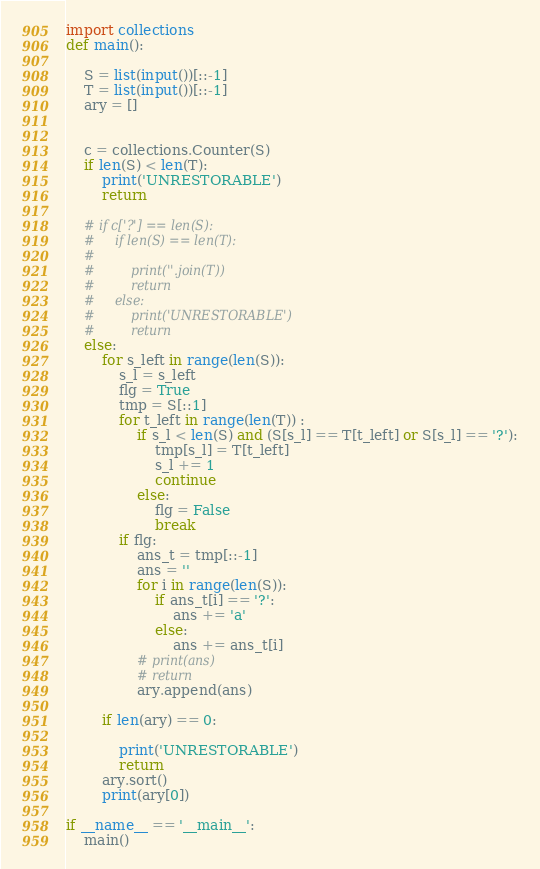Convert code to text. <code><loc_0><loc_0><loc_500><loc_500><_Python_>import collections
def main():

    S = list(input())[::-1]
    T = list(input())[::-1]
    ary = []


    c = collections.Counter(S)
    if len(S) < len(T):
        print('UNRESTORABLE')
        return

    # if c['?'] == len(S):
    #     if len(S) == len(T):
    #
    #         print(''.join(T))
    #         return
    #     else:
    #         print('UNRESTORABLE')
    #         return
    else:
        for s_left in range(len(S)):
            s_l = s_left
            flg = True
            tmp = S[::1]
            for t_left in range(len(T)) :
                if s_l < len(S) and (S[s_l] == T[t_left] or S[s_l] == '?'):
                    tmp[s_l] = T[t_left]
                    s_l += 1
                    continue
                else:
                    flg = False
                    break
            if flg:
                ans_t = tmp[::-1]
                ans = ''
                for i in range(len(S)):
                    if ans_t[i] == '?':
                        ans += 'a'
                    else:
                        ans += ans_t[i]
                # print(ans)
                # return
                ary.append(ans)

        if len(ary) == 0:

            print('UNRESTORABLE')
            return
        ary.sort()
        print(ary[0])

if __name__ == '__main__':
    main()
</code> 